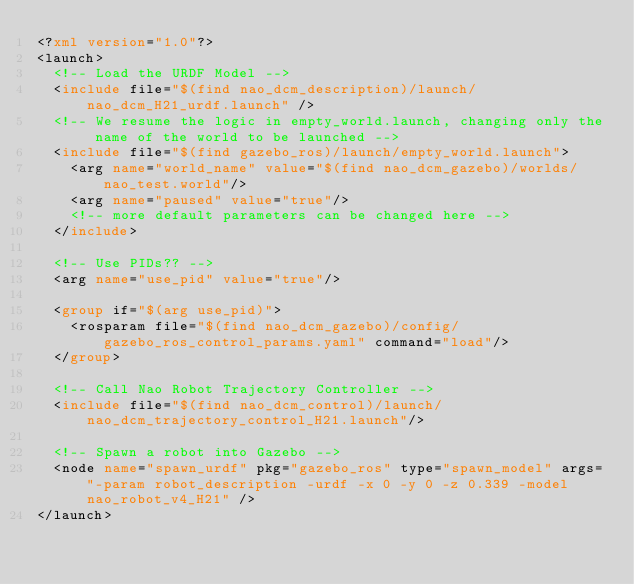Convert code to text. <code><loc_0><loc_0><loc_500><loc_500><_XML_><?xml version="1.0"?>
<launch>
  <!-- Load the URDF Model -->
  <include file="$(find nao_dcm_description)/launch/nao_dcm_H21_urdf.launch" />
  <!-- We resume the logic in empty_world.launch, changing only the name of the world to be launched -->
  <include file="$(find gazebo_ros)/launch/empty_world.launch">
    <arg name="world_name" value="$(find nao_dcm_gazebo)/worlds/nao_test.world"/>
    <arg name="paused" value="true"/>
    <!-- more default parameters can be changed here -->
  </include>

  <!-- Use PIDs?? -->
  <arg name="use_pid" value="true"/>

  <group if="$(arg use_pid)">
    <rosparam file="$(find nao_dcm_gazebo)/config/gazebo_ros_control_params.yaml" command="load"/>
  </group>

  <!-- Call Nao Robot Trajectory Controller -->
  <include file="$(find nao_dcm_control)/launch/nao_dcm_trajectory_control_H21.launch"/>
  
  <!-- Spawn a robot into Gazebo -->
  <node name="spawn_urdf" pkg="gazebo_ros" type="spawn_model" args="-param robot_description -urdf -x 0 -y 0 -z 0.339 -model nao_robot_v4_H21" />
</launch></code> 